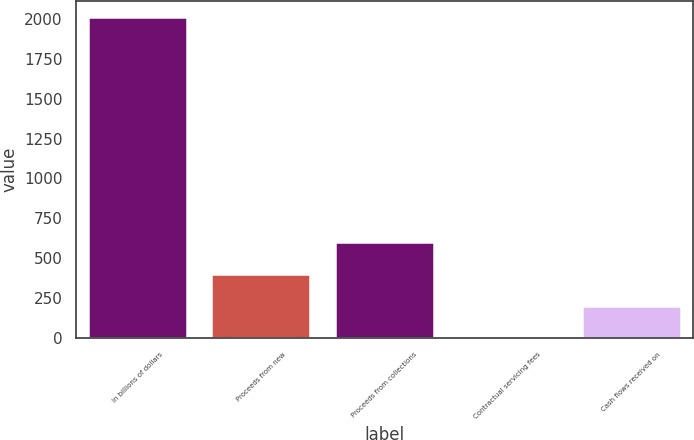Convert chart. <chart><loc_0><loc_0><loc_500><loc_500><bar_chart><fcel>In billions of dollars<fcel>Proceeds from new<fcel>Proceeds from collections<fcel>Contractual servicing fees<fcel>Cash flows received on<nl><fcel>2009<fcel>402.84<fcel>603.61<fcel>1.3<fcel>202.07<nl></chart> 